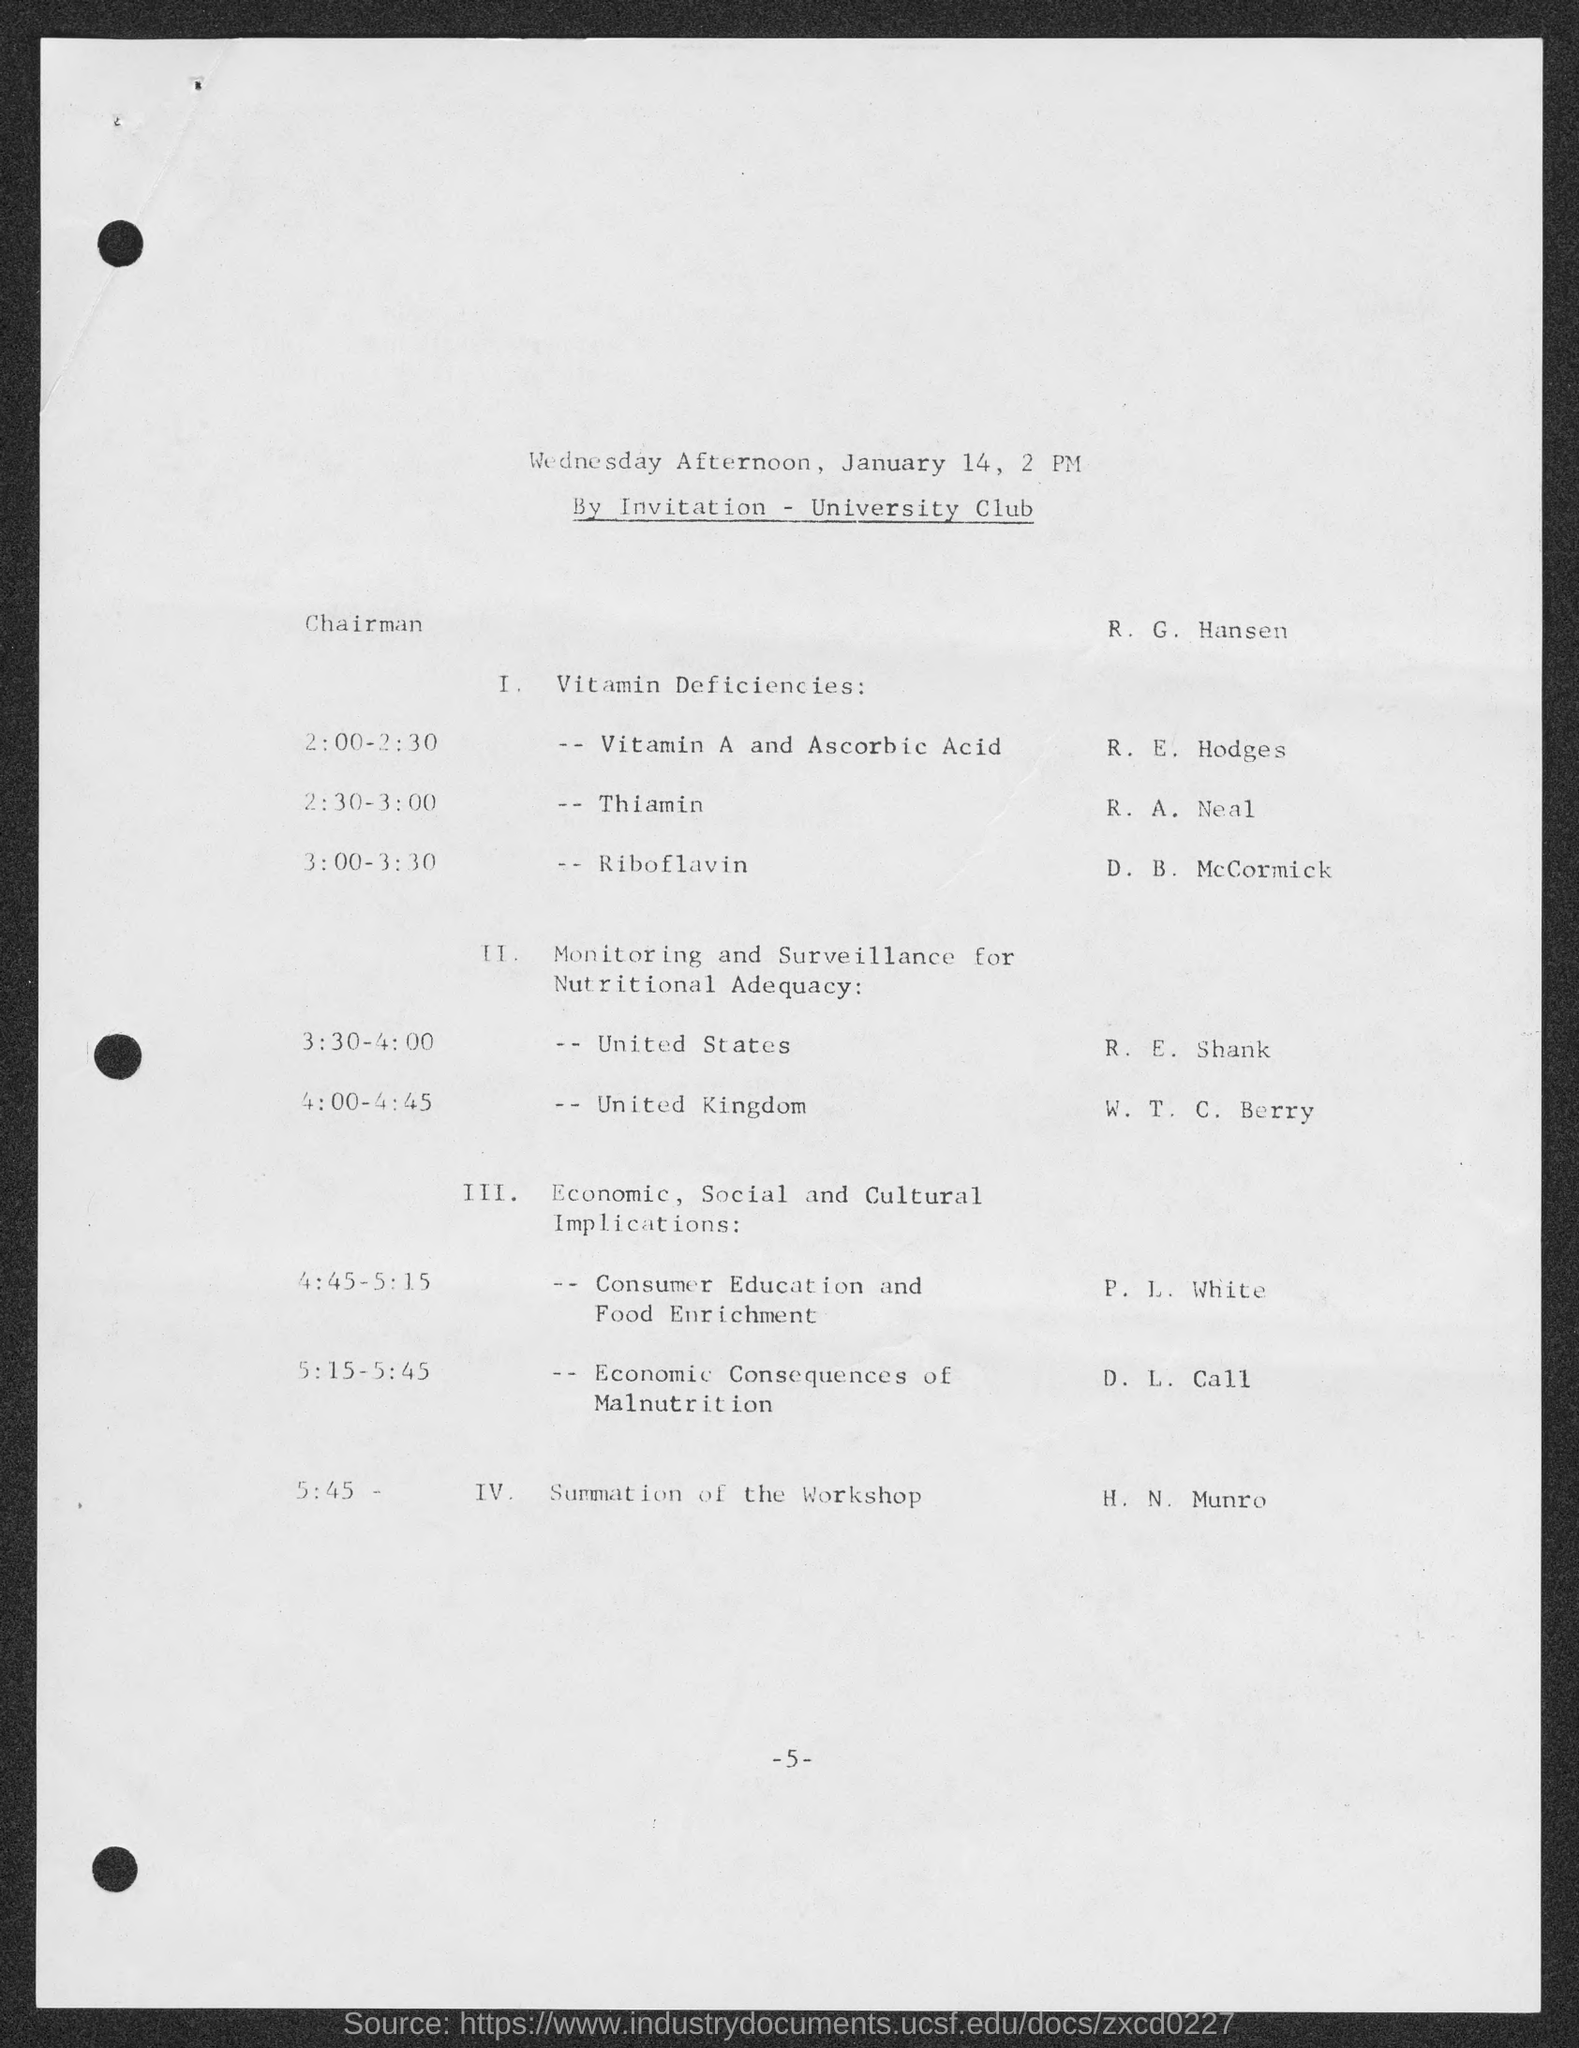Identify some key points in this picture. The number at the bottom of the page is 5. 